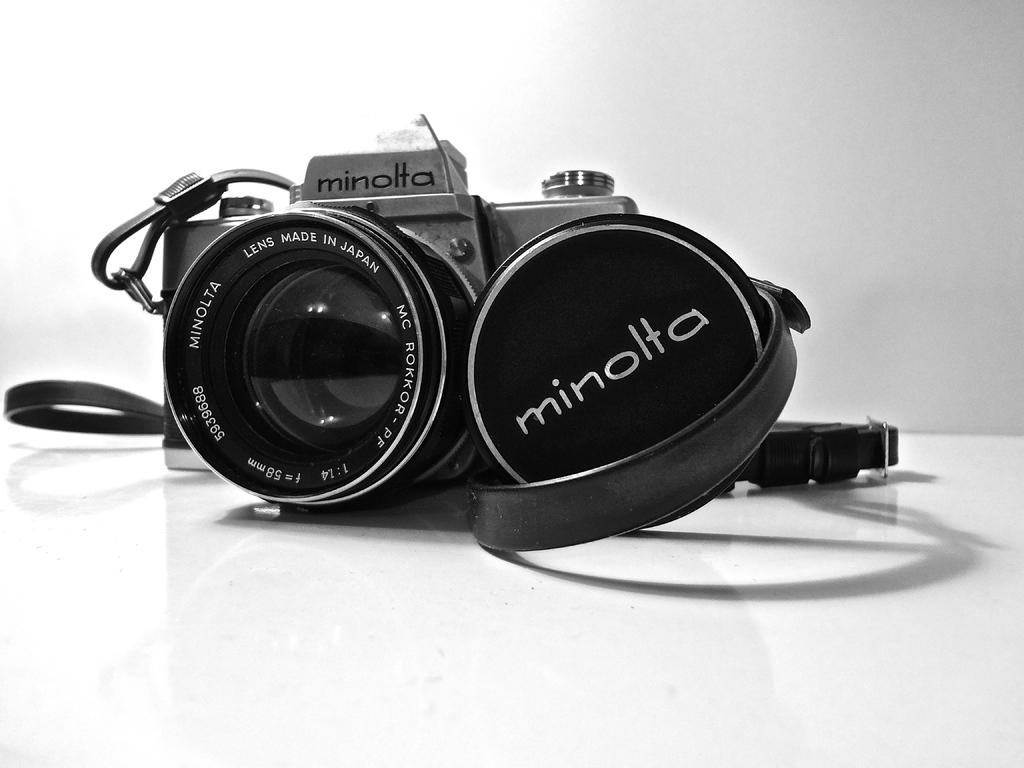What is the main object in the image? There is a camera in the image. What feature is attached to the camera? The camera has a strap. What color is the background of the image? The background of the image is white. What type of instrument is being played by the group in the image? There is no group or instrument present in the image; it only features a camera with a strap against a white background. 